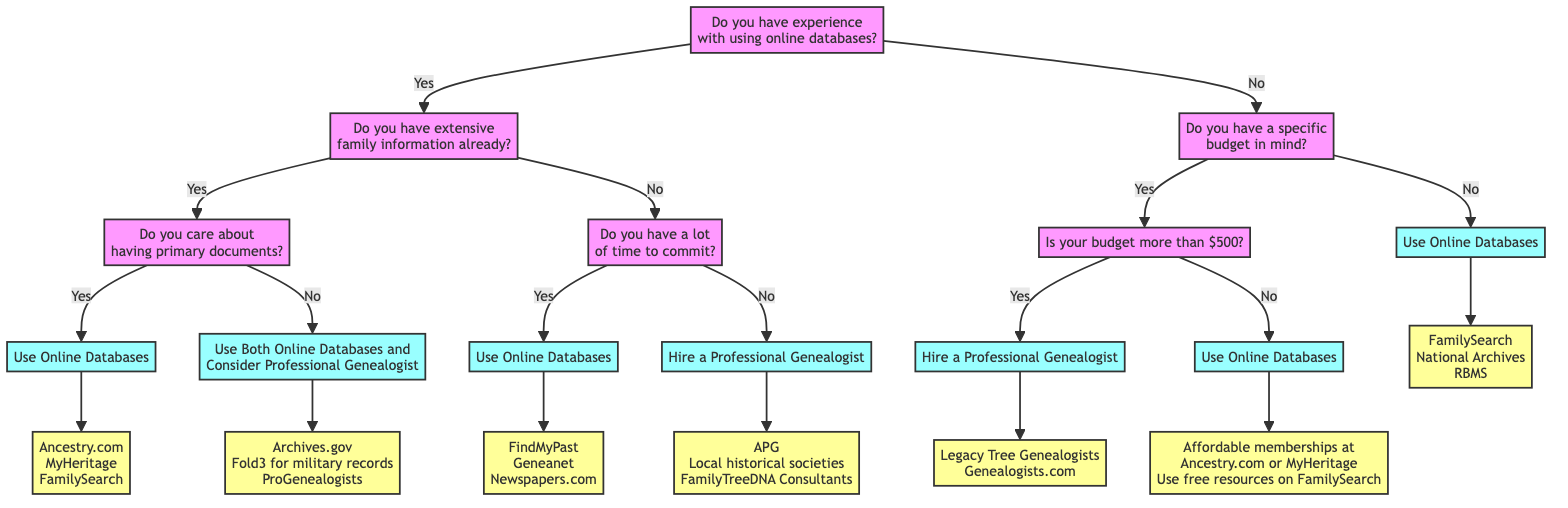What is the first question in the decision tree? The first question at the top of the decision tree is about having experience with using online databases.
Answer: Do you have experience with using online databases? How many outcomes lead to hiring a professional genealogist? By tracing the branches of the decision tree, we can find that there are three outcomes leading to hiring a professional genealogist: (1) If the user doesn't have online experience and the budget is more than $500, (2) If the user has no experience, has a specific budget, and does not have a lot of time to commit.
Answer: Three outcomes What are the recommendations if you choose to use both online databases and consider hiring a professional genealogist? If a user chooses to use both online databases and consider hiring a professional genealogist, the recommendations provided are Archives.gov, Fold3 for military records, and ProGenealogists.
Answer: Archives.gov, Fold3 for military records, ProGenealogists If someone has online experience and a lot of time to commit, what should they do? In this scenario, the decision tree indicates that the best approach is to use online databases, suggesting recommendations such as FindMyPast, Geneanet, and Newspapers.com.
Answer: Use Online Databases What specific questions guide the decision-making process related to budget in the tree? The decision-making process related to budget is guided by two specific questions: (1) Do you have a specific budget in mind? (2) Is your budget more than $500?
Answer: Do you have a specific budget in mind? Is your budget more than $500? Which online databases are suggested for those who have no experience with online databases and a specific budget under $500? The recommended online databases for users who have no experience and a budget under $500 include affordable memberships at Ancestry.com, MyHeritage, and using free resources on FamilySearch.
Answer: Affordable memberships at Ancestry.com or MyHeritage, Use free resources on FamilySearch How does the tree categorize the need for primary documents? The tree categorizes the need for primary documents as a factor that can lead users who have extensive family information to either use online databases or consider both online databases and hiring a professional genealogist.
Answer: Do you care about having primary documents? What is the result if a user has no online experience and their budget is less than $500? If a user has no online experience and their budget is less than $500, the result suggests they should use online databases, recommending FamilySearch, the National Archives, and RBMS.
Answer: Use Online Databases 